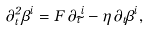<formula> <loc_0><loc_0><loc_500><loc_500>\partial ^ { 2 } _ { t } \beta ^ { i } = F \, \partial _ { t } \tilde { \Gamma } ^ { i } - \eta \, \partial _ { t } \beta ^ { i } ,</formula> 